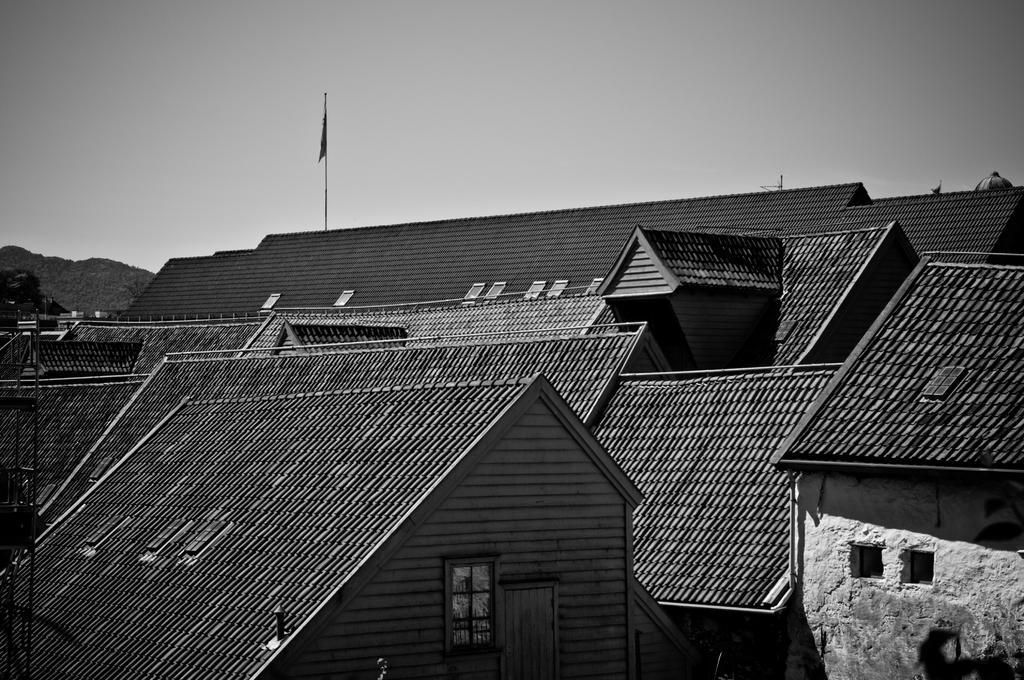In one or two sentences, can you explain what this image depicts? In this image we can see group of buildings ,a flag on a pole. In the background ,we can see the sky. 